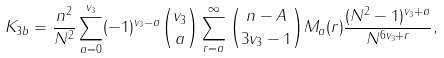<formula> <loc_0><loc_0><loc_500><loc_500>K _ { 3 b } = \frac { n ^ { 2 } } { N ^ { 2 } } \sum _ { a = 0 } ^ { v _ { 3 } } ( - 1 ) ^ { { v _ { 3 } } - a } \binom { v _ { 3 } } { a } \sum _ { r = a } ^ { \infty } \binom { n - A } { 3 v _ { 3 } - 1 } M _ { a } ( r ) \frac { ( N ^ { 2 } - 1 ) ^ { v _ { 3 } + a } } { N ^ { 6 v _ { 3 } + r } } ,</formula> 